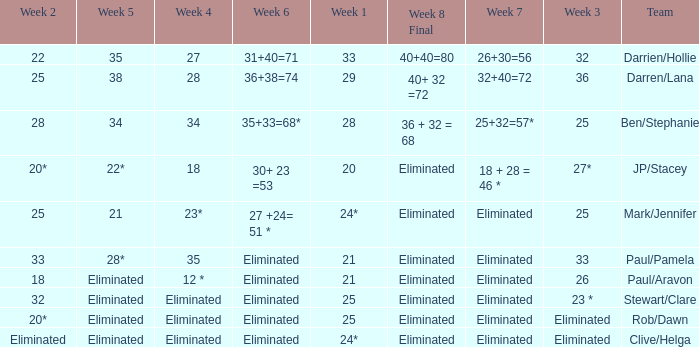Name the week 3 of 36 29.0. 